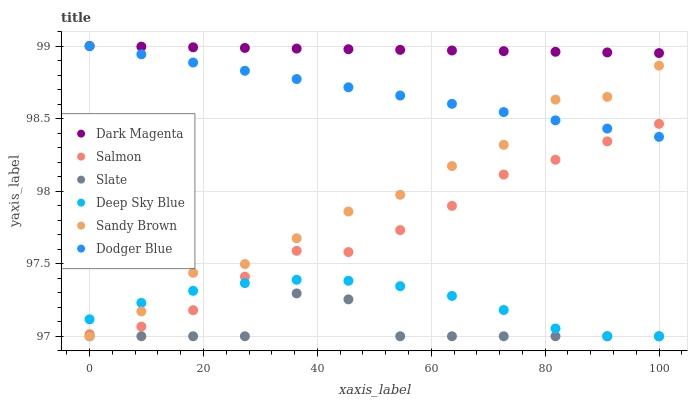Does Slate have the minimum area under the curve?
Answer yes or no. Yes. Does Dark Magenta have the maximum area under the curve?
Answer yes or no. Yes. Does Salmon have the minimum area under the curve?
Answer yes or no. No. Does Salmon have the maximum area under the curve?
Answer yes or no. No. Is Dark Magenta the smoothest?
Answer yes or no. Yes. Is Sandy Brown the roughest?
Answer yes or no. Yes. Is Slate the smoothest?
Answer yes or no. No. Is Slate the roughest?
Answer yes or no. No. Does Slate have the lowest value?
Answer yes or no. Yes. Does Salmon have the lowest value?
Answer yes or no. No. Does Dodger Blue have the highest value?
Answer yes or no. Yes. Does Salmon have the highest value?
Answer yes or no. No. Is Slate less than Salmon?
Answer yes or no. Yes. Is Dark Magenta greater than Salmon?
Answer yes or no. Yes. Does Dodger Blue intersect Sandy Brown?
Answer yes or no. Yes. Is Dodger Blue less than Sandy Brown?
Answer yes or no. No. Is Dodger Blue greater than Sandy Brown?
Answer yes or no. No. Does Slate intersect Salmon?
Answer yes or no. No. 